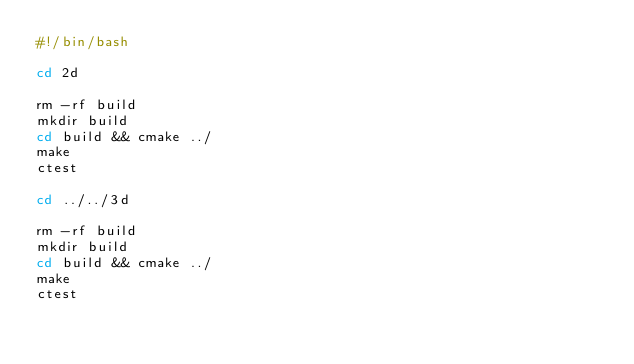<code> <loc_0><loc_0><loc_500><loc_500><_Bash_>#!/bin/bash

cd 2d

rm -rf build
mkdir build
cd build && cmake ../
make
ctest

cd ../../3d

rm -rf build
mkdir build
cd build && cmake ../
make
ctest

</code> 